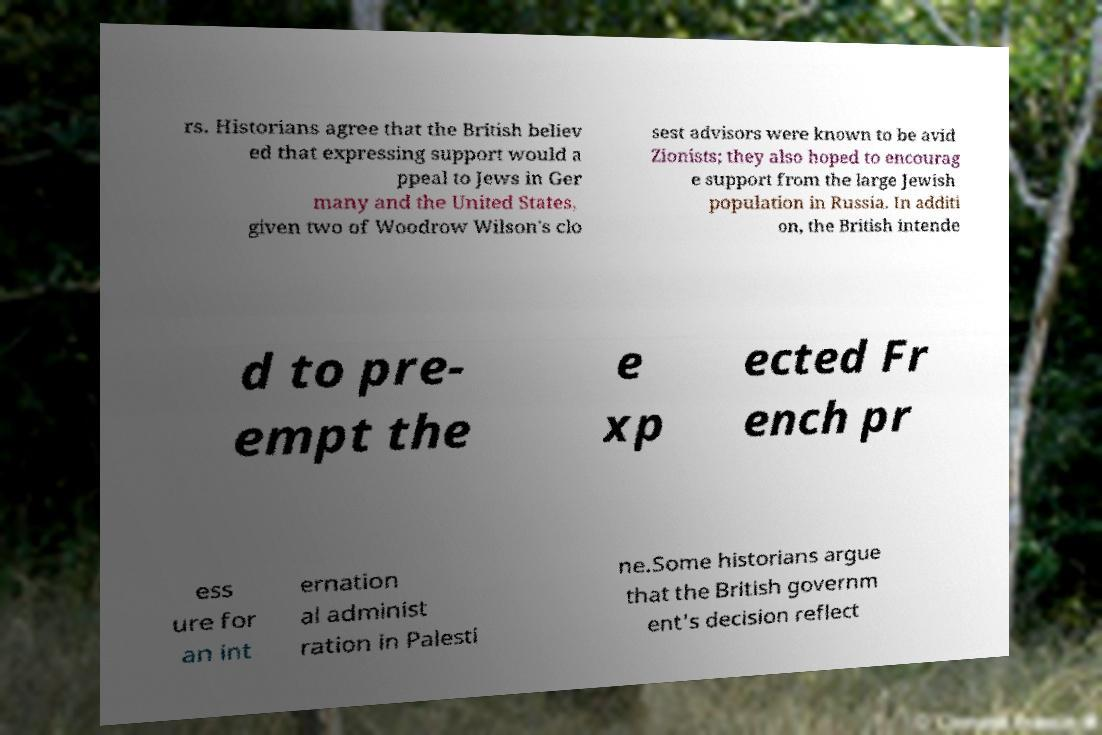Could you extract and type out the text from this image? rs. Historians agree that the British believ ed that expressing support would a ppeal to Jews in Ger many and the United States, given two of Woodrow Wilson's clo sest advisors were known to be avid Zionists; they also hoped to encourag e support from the large Jewish population in Russia. In additi on, the British intende d to pre- empt the e xp ected Fr ench pr ess ure for an int ernation al administ ration in Palesti ne.Some historians argue that the British governm ent's decision reflect 